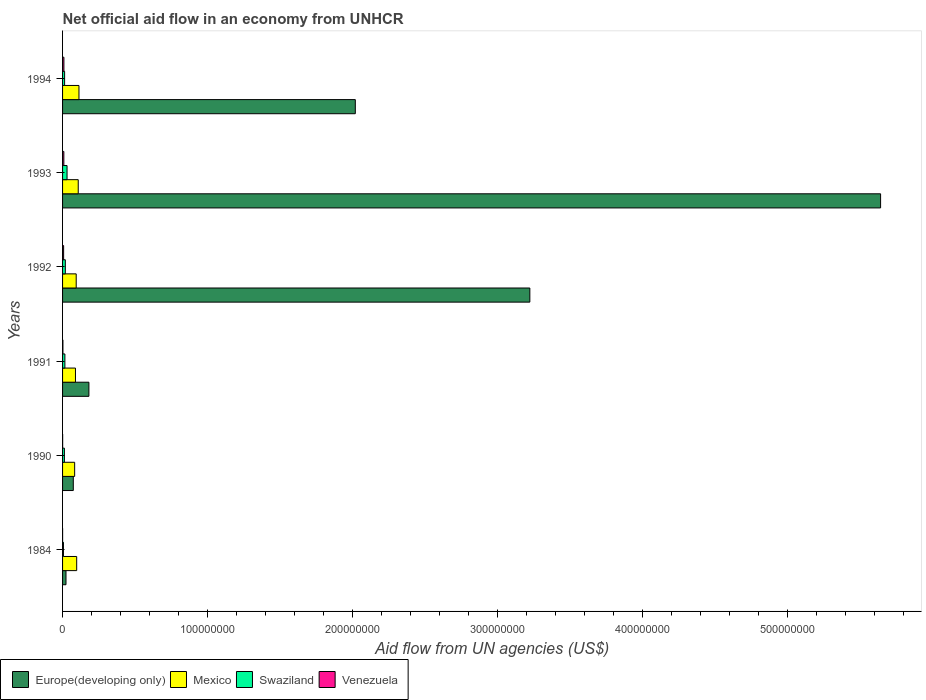Are the number of bars on each tick of the Y-axis equal?
Give a very brief answer. Yes. How many bars are there on the 2nd tick from the top?
Your answer should be compact. 4. What is the label of the 4th group of bars from the top?
Make the answer very short. 1991. In how many cases, is the number of bars for a given year not equal to the number of legend labels?
Give a very brief answer. 0. What is the net official aid flow in Venezuela in 1993?
Your answer should be compact. 8.80e+05. Across all years, what is the maximum net official aid flow in Europe(developing only)?
Keep it short and to the point. 5.64e+08. Across all years, what is the minimum net official aid flow in Venezuela?
Provide a short and direct response. 2.00e+04. What is the total net official aid flow in Europe(developing only) in the graph?
Keep it short and to the point. 1.12e+09. What is the difference between the net official aid flow in Europe(developing only) in 1984 and that in 1994?
Your answer should be very brief. -2.00e+08. What is the difference between the net official aid flow in Mexico in 1990 and the net official aid flow in Europe(developing only) in 1984?
Keep it short and to the point. 5.97e+06. What is the average net official aid flow in Mexico per year?
Give a very brief answer. 9.75e+06. In the year 1990, what is the difference between the net official aid flow in Mexico and net official aid flow in Venezuela?
Offer a very short reply. 8.29e+06. In how many years, is the net official aid flow in Swaziland greater than 200000000 US$?
Offer a terse response. 0. What is the ratio of the net official aid flow in Europe(developing only) in 1992 to that in 1994?
Keep it short and to the point. 1.6. Is the net official aid flow in Swaziland in 1990 less than that in 1993?
Ensure brevity in your answer.  Yes. What is the difference between the highest and the second highest net official aid flow in Venezuela?
Offer a terse response. 4.00e+04. What does the 2nd bar from the top in 1993 represents?
Provide a short and direct response. Swaziland. What does the 4th bar from the bottom in 1990 represents?
Keep it short and to the point. Venezuela. Is it the case that in every year, the sum of the net official aid flow in Mexico and net official aid flow in Venezuela is greater than the net official aid flow in Swaziland?
Your response must be concise. Yes. How many years are there in the graph?
Your response must be concise. 6. What is the difference between two consecutive major ticks on the X-axis?
Ensure brevity in your answer.  1.00e+08. Are the values on the major ticks of X-axis written in scientific E-notation?
Offer a terse response. No. Where does the legend appear in the graph?
Your answer should be very brief. Bottom left. How are the legend labels stacked?
Offer a very short reply. Horizontal. What is the title of the graph?
Make the answer very short. Net official aid flow in an economy from UNHCR. What is the label or title of the X-axis?
Provide a succinct answer. Aid flow from UN agencies (US$). What is the label or title of the Y-axis?
Provide a short and direct response. Years. What is the Aid flow from UN agencies (US$) of Europe(developing only) in 1984?
Provide a short and direct response. 2.37e+06. What is the Aid flow from UN agencies (US$) of Mexico in 1984?
Provide a succinct answer. 9.74e+06. What is the Aid flow from UN agencies (US$) of Europe(developing only) in 1990?
Provide a short and direct response. 7.40e+06. What is the Aid flow from UN agencies (US$) in Mexico in 1990?
Make the answer very short. 8.34e+06. What is the Aid flow from UN agencies (US$) in Swaziland in 1990?
Provide a short and direct response. 1.27e+06. What is the Aid flow from UN agencies (US$) in Europe(developing only) in 1991?
Ensure brevity in your answer.  1.82e+07. What is the Aid flow from UN agencies (US$) of Mexico in 1991?
Give a very brief answer. 8.90e+06. What is the Aid flow from UN agencies (US$) of Swaziland in 1991?
Offer a terse response. 1.60e+06. What is the Aid flow from UN agencies (US$) of Europe(developing only) in 1992?
Make the answer very short. 3.22e+08. What is the Aid flow from UN agencies (US$) of Mexico in 1992?
Your answer should be very brief. 9.40e+06. What is the Aid flow from UN agencies (US$) in Swaziland in 1992?
Offer a very short reply. 1.90e+06. What is the Aid flow from UN agencies (US$) of Venezuela in 1992?
Provide a short and direct response. 7.30e+05. What is the Aid flow from UN agencies (US$) of Europe(developing only) in 1993?
Provide a succinct answer. 5.64e+08. What is the Aid flow from UN agencies (US$) of Mexico in 1993?
Ensure brevity in your answer.  1.08e+07. What is the Aid flow from UN agencies (US$) in Swaziland in 1993?
Your answer should be compact. 3.09e+06. What is the Aid flow from UN agencies (US$) of Venezuela in 1993?
Offer a terse response. 8.80e+05. What is the Aid flow from UN agencies (US$) of Europe(developing only) in 1994?
Offer a terse response. 2.02e+08. What is the Aid flow from UN agencies (US$) in Mexico in 1994?
Your answer should be compact. 1.13e+07. What is the Aid flow from UN agencies (US$) in Swaziland in 1994?
Make the answer very short. 1.41e+06. What is the Aid flow from UN agencies (US$) of Venezuela in 1994?
Your answer should be compact. 9.20e+05. Across all years, what is the maximum Aid flow from UN agencies (US$) in Europe(developing only)?
Provide a succinct answer. 5.64e+08. Across all years, what is the maximum Aid flow from UN agencies (US$) of Mexico?
Your response must be concise. 1.13e+07. Across all years, what is the maximum Aid flow from UN agencies (US$) of Swaziland?
Your response must be concise. 3.09e+06. Across all years, what is the maximum Aid flow from UN agencies (US$) of Venezuela?
Your answer should be compact. 9.20e+05. Across all years, what is the minimum Aid flow from UN agencies (US$) in Europe(developing only)?
Your answer should be compact. 2.37e+06. Across all years, what is the minimum Aid flow from UN agencies (US$) of Mexico?
Your response must be concise. 8.34e+06. What is the total Aid flow from UN agencies (US$) of Europe(developing only) in the graph?
Your response must be concise. 1.12e+09. What is the total Aid flow from UN agencies (US$) in Mexico in the graph?
Provide a short and direct response. 5.85e+07. What is the total Aid flow from UN agencies (US$) in Swaziland in the graph?
Make the answer very short. 9.88e+06. What is the total Aid flow from UN agencies (US$) in Venezuela in the graph?
Your answer should be compact. 2.85e+06. What is the difference between the Aid flow from UN agencies (US$) in Europe(developing only) in 1984 and that in 1990?
Offer a terse response. -5.03e+06. What is the difference between the Aid flow from UN agencies (US$) of Mexico in 1984 and that in 1990?
Give a very brief answer. 1.40e+06. What is the difference between the Aid flow from UN agencies (US$) in Swaziland in 1984 and that in 1990?
Your answer should be compact. -6.60e+05. What is the difference between the Aid flow from UN agencies (US$) in Europe(developing only) in 1984 and that in 1991?
Keep it short and to the point. -1.58e+07. What is the difference between the Aid flow from UN agencies (US$) in Mexico in 1984 and that in 1991?
Offer a very short reply. 8.40e+05. What is the difference between the Aid flow from UN agencies (US$) in Swaziland in 1984 and that in 1991?
Offer a very short reply. -9.90e+05. What is the difference between the Aid flow from UN agencies (US$) of Europe(developing only) in 1984 and that in 1992?
Offer a terse response. -3.20e+08. What is the difference between the Aid flow from UN agencies (US$) in Swaziland in 1984 and that in 1992?
Ensure brevity in your answer.  -1.29e+06. What is the difference between the Aid flow from UN agencies (US$) of Venezuela in 1984 and that in 1992?
Offer a terse response. -7.10e+05. What is the difference between the Aid flow from UN agencies (US$) of Europe(developing only) in 1984 and that in 1993?
Ensure brevity in your answer.  -5.62e+08. What is the difference between the Aid flow from UN agencies (US$) in Mexico in 1984 and that in 1993?
Your answer should be compact. -1.07e+06. What is the difference between the Aid flow from UN agencies (US$) in Swaziland in 1984 and that in 1993?
Provide a succinct answer. -2.48e+06. What is the difference between the Aid flow from UN agencies (US$) of Venezuela in 1984 and that in 1993?
Your response must be concise. -8.60e+05. What is the difference between the Aid flow from UN agencies (US$) in Europe(developing only) in 1984 and that in 1994?
Offer a very short reply. -2.00e+08. What is the difference between the Aid flow from UN agencies (US$) in Mexico in 1984 and that in 1994?
Your answer should be very brief. -1.57e+06. What is the difference between the Aid flow from UN agencies (US$) in Swaziland in 1984 and that in 1994?
Keep it short and to the point. -8.00e+05. What is the difference between the Aid flow from UN agencies (US$) in Venezuela in 1984 and that in 1994?
Make the answer very short. -9.00e+05. What is the difference between the Aid flow from UN agencies (US$) of Europe(developing only) in 1990 and that in 1991?
Your response must be concise. -1.08e+07. What is the difference between the Aid flow from UN agencies (US$) of Mexico in 1990 and that in 1991?
Provide a succinct answer. -5.60e+05. What is the difference between the Aid flow from UN agencies (US$) of Swaziland in 1990 and that in 1991?
Your answer should be compact. -3.30e+05. What is the difference between the Aid flow from UN agencies (US$) in Venezuela in 1990 and that in 1991?
Your answer should be very brief. -2.00e+05. What is the difference between the Aid flow from UN agencies (US$) of Europe(developing only) in 1990 and that in 1992?
Your answer should be very brief. -3.15e+08. What is the difference between the Aid flow from UN agencies (US$) of Mexico in 1990 and that in 1992?
Provide a short and direct response. -1.06e+06. What is the difference between the Aid flow from UN agencies (US$) of Swaziland in 1990 and that in 1992?
Offer a very short reply. -6.30e+05. What is the difference between the Aid flow from UN agencies (US$) of Venezuela in 1990 and that in 1992?
Your answer should be compact. -6.80e+05. What is the difference between the Aid flow from UN agencies (US$) in Europe(developing only) in 1990 and that in 1993?
Ensure brevity in your answer.  -5.57e+08. What is the difference between the Aid flow from UN agencies (US$) of Mexico in 1990 and that in 1993?
Your response must be concise. -2.47e+06. What is the difference between the Aid flow from UN agencies (US$) of Swaziland in 1990 and that in 1993?
Your answer should be very brief. -1.82e+06. What is the difference between the Aid flow from UN agencies (US$) of Venezuela in 1990 and that in 1993?
Provide a short and direct response. -8.30e+05. What is the difference between the Aid flow from UN agencies (US$) in Europe(developing only) in 1990 and that in 1994?
Make the answer very short. -1.94e+08. What is the difference between the Aid flow from UN agencies (US$) of Mexico in 1990 and that in 1994?
Make the answer very short. -2.97e+06. What is the difference between the Aid flow from UN agencies (US$) of Swaziland in 1990 and that in 1994?
Provide a short and direct response. -1.40e+05. What is the difference between the Aid flow from UN agencies (US$) in Venezuela in 1990 and that in 1994?
Keep it short and to the point. -8.70e+05. What is the difference between the Aid flow from UN agencies (US$) of Europe(developing only) in 1991 and that in 1992?
Offer a very short reply. -3.04e+08. What is the difference between the Aid flow from UN agencies (US$) of Mexico in 1991 and that in 1992?
Offer a very short reply. -5.00e+05. What is the difference between the Aid flow from UN agencies (US$) in Venezuela in 1991 and that in 1992?
Provide a short and direct response. -4.80e+05. What is the difference between the Aid flow from UN agencies (US$) in Europe(developing only) in 1991 and that in 1993?
Your answer should be compact. -5.46e+08. What is the difference between the Aid flow from UN agencies (US$) in Mexico in 1991 and that in 1993?
Your answer should be very brief. -1.91e+06. What is the difference between the Aid flow from UN agencies (US$) of Swaziland in 1991 and that in 1993?
Your response must be concise. -1.49e+06. What is the difference between the Aid flow from UN agencies (US$) in Venezuela in 1991 and that in 1993?
Ensure brevity in your answer.  -6.30e+05. What is the difference between the Aid flow from UN agencies (US$) in Europe(developing only) in 1991 and that in 1994?
Your answer should be very brief. -1.84e+08. What is the difference between the Aid flow from UN agencies (US$) of Mexico in 1991 and that in 1994?
Your answer should be compact. -2.41e+06. What is the difference between the Aid flow from UN agencies (US$) in Swaziland in 1991 and that in 1994?
Your answer should be compact. 1.90e+05. What is the difference between the Aid flow from UN agencies (US$) of Venezuela in 1991 and that in 1994?
Provide a short and direct response. -6.70e+05. What is the difference between the Aid flow from UN agencies (US$) in Europe(developing only) in 1992 and that in 1993?
Keep it short and to the point. -2.42e+08. What is the difference between the Aid flow from UN agencies (US$) of Mexico in 1992 and that in 1993?
Offer a very short reply. -1.41e+06. What is the difference between the Aid flow from UN agencies (US$) in Swaziland in 1992 and that in 1993?
Your answer should be compact. -1.19e+06. What is the difference between the Aid flow from UN agencies (US$) in Venezuela in 1992 and that in 1993?
Provide a short and direct response. -1.50e+05. What is the difference between the Aid flow from UN agencies (US$) in Europe(developing only) in 1992 and that in 1994?
Your answer should be very brief. 1.20e+08. What is the difference between the Aid flow from UN agencies (US$) of Mexico in 1992 and that in 1994?
Your answer should be very brief. -1.91e+06. What is the difference between the Aid flow from UN agencies (US$) of Venezuela in 1992 and that in 1994?
Keep it short and to the point. -1.90e+05. What is the difference between the Aid flow from UN agencies (US$) in Europe(developing only) in 1993 and that in 1994?
Provide a short and direct response. 3.62e+08. What is the difference between the Aid flow from UN agencies (US$) in Mexico in 1993 and that in 1994?
Provide a short and direct response. -5.00e+05. What is the difference between the Aid flow from UN agencies (US$) in Swaziland in 1993 and that in 1994?
Ensure brevity in your answer.  1.68e+06. What is the difference between the Aid flow from UN agencies (US$) in Europe(developing only) in 1984 and the Aid flow from UN agencies (US$) in Mexico in 1990?
Your response must be concise. -5.97e+06. What is the difference between the Aid flow from UN agencies (US$) in Europe(developing only) in 1984 and the Aid flow from UN agencies (US$) in Swaziland in 1990?
Your answer should be compact. 1.10e+06. What is the difference between the Aid flow from UN agencies (US$) of Europe(developing only) in 1984 and the Aid flow from UN agencies (US$) of Venezuela in 1990?
Your answer should be very brief. 2.32e+06. What is the difference between the Aid flow from UN agencies (US$) in Mexico in 1984 and the Aid flow from UN agencies (US$) in Swaziland in 1990?
Offer a terse response. 8.47e+06. What is the difference between the Aid flow from UN agencies (US$) in Mexico in 1984 and the Aid flow from UN agencies (US$) in Venezuela in 1990?
Your answer should be very brief. 9.69e+06. What is the difference between the Aid flow from UN agencies (US$) of Swaziland in 1984 and the Aid flow from UN agencies (US$) of Venezuela in 1990?
Provide a short and direct response. 5.60e+05. What is the difference between the Aid flow from UN agencies (US$) in Europe(developing only) in 1984 and the Aid flow from UN agencies (US$) in Mexico in 1991?
Your answer should be very brief. -6.53e+06. What is the difference between the Aid flow from UN agencies (US$) in Europe(developing only) in 1984 and the Aid flow from UN agencies (US$) in Swaziland in 1991?
Keep it short and to the point. 7.70e+05. What is the difference between the Aid flow from UN agencies (US$) in Europe(developing only) in 1984 and the Aid flow from UN agencies (US$) in Venezuela in 1991?
Your answer should be compact. 2.12e+06. What is the difference between the Aid flow from UN agencies (US$) in Mexico in 1984 and the Aid flow from UN agencies (US$) in Swaziland in 1991?
Your response must be concise. 8.14e+06. What is the difference between the Aid flow from UN agencies (US$) of Mexico in 1984 and the Aid flow from UN agencies (US$) of Venezuela in 1991?
Your answer should be very brief. 9.49e+06. What is the difference between the Aid flow from UN agencies (US$) of Swaziland in 1984 and the Aid flow from UN agencies (US$) of Venezuela in 1991?
Your response must be concise. 3.60e+05. What is the difference between the Aid flow from UN agencies (US$) in Europe(developing only) in 1984 and the Aid flow from UN agencies (US$) in Mexico in 1992?
Provide a succinct answer. -7.03e+06. What is the difference between the Aid flow from UN agencies (US$) of Europe(developing only) in 1984 and the Aid flow from UN agencies (US$) of Venezuela in 1992?
Keep it short and to the point. 1.64e+06. What is the difference between the Aid flow from UN agencies (US$) in Mexico in 1984 and the Aid flow from UN agencies (US$) in Swaziland in 1992?
Keep it short and to the point. 7.84e+06. What is the difference between the Aid flow from UN agencies (US$) in Mexico in 1984 and the Aid flow from UN agencies (US$) in Venezuela in 1992?
Your answer should be very brief. 9.01e+06. What is the difference between the Aid flow from UN agencies (US$) in Swaziland in 1984 and the Aid flow from UN agencies (US$) in Venezuela in 1992?
Provide a succinct answer. -1.20e+05. What is the difference between the Aid flow from UN agencies (US$) in Europe(developing only) in 1984 and the Aid flow from UN agencies (US$) in Mexico in 1993?
Make the answer very short. -8.44e+06. What is the difference between the Aid flow from UN agencies (US$) in Europe(developing only) in 1984 and the Aid flow from UN agencies (US$) in Swaziland in 1993?
Your answer should be very brief. -7.20e+05. What is the difference between the Aid flow from UN agencies (US$) in Europe(developing only) in 1984 and the Aid flow from UN agencies (US$) in Venezuela in 1993?
Provide a short and direct response. 1.49e+06. What is the difference between the Aid flow from UN agencies (US$) in Mexico in 1984 and the Aid flow from UN agencies (US$) in Swaziland in 1993?
Make the answer very short. 6.65e+06. What is the difference between the Aid flow from UN agencies (US$) of Mexico in 1984 and the Aid flow from UN agencies (US$) of Venezuela in 1993?
Ensure brevity in your answer.  8.86e+06. What is the difference between the Aid flow from UN agencies (US$) of Swaziland in 1984 and the Aid flow from UN agencies (US$) of Venezuela in 1993?
Offer a terse response. -2.70e+05. What is the difference between the Aid flow from UN agencies (US$) in Europe(developing only) in 1984 and the Aid flow from UN agencies (US$) in Mexico in 1994?
Give a very brief answer. -8.94e+06. What is the difference between the Aid flow from UN agencies (US$) in Europe(developing only) in 1984 and the Aid flow from UN agencies (US$) in Swaziland in 1994?
Your answer should be very brief. 9.60e+05. What is the difference between the Aid flow from UN agencies (US$) in Europe(developing only) in 1984 and the Aid flow from UN agencies (US$) in Venezuela in 1994?
Ensure brevity in your answer.  1.45e+06. What is the difference between the Aid flow from UN agencies (US$) in Mexico in 1984 and the Aid flow from UN agencies (US$) in Swaziland in 1994?
Keep it short and to the point. 8.33e+06. What is the difference between the Aid flow from UN agencies (US$) of Mexico in 1984 and the Aid flow from UN agencies (US$) of Venezuela in 1994?
Your response must be concise. 8.82e+06. What is the difference between the Aid flow from UN agencies (US$) in Swaziland in 1984 and the Aid flow from UN agencies (US$) in Venezuela in 1994?
Give a very brief answer. -3.10e+05. What is the difference between the Aid flow from UN agencies (US$) of Europe(developing only) in 1990 and the Aid flow from UN agencies (US$) of Mexico in 1991?
Offer a very short reply. -1.50e+06. What is the difference between the Aid flow from UN agencies (US$) in Europe(developing only) in 1990 and the Aid flow from UN agencies (US$) in Swaziland in 1991?
Provide a short and direct response. 5.80e+06. What is the difference between the Aid flow from UN agencies (US$) in Europe(developing only) in 1990 and the Aid flow from UN agencies (US$) in Venezuela in 1991?
Provide a succinct answer. 7.15e+06. What is the difference between the Aid flow from UN agencies (US$) in Mexico in 1990 and the Aid flow from UN agencies (US$) in Swaziland in 1991?
Your answer should be compact. 6.74e+06. What is the difference between the Aid flow from UN agencies (US$) in Mexico in 1990 and the Aid flow from UN agencies (US$) in Venezuela in 1991?
Ensure brevity in your answer.  8.09e+06. What is the difference between the Aid flow from UN agencies (US$) of Swaziland in 1990 and the Aid flow from UN agencies (US$) of Venezuela in 1991?
Provide a short and direct response. 1.02e+06. What is the difference between the Aid flow from UN agencies (US$) of Europe(developing only) in 1990 and the Aid flow from UN agencies (US$) of Mexico in 1992?
Provide a succinct answer. -2.00e+06. What is the difference between the Aid flow from UN agencies (US$) in Europe(developing only) in 1990 and the Aid flow from UN agencies (US$) in Swaziland in 1992?
Your answer should be compact. 5.50e+06. What is the difference between the Aid flow from UN agencies (US$) of Europe(developing only) in 1990 and the Aid flow from UN agencies (US$) of Venezuela in 1992?
Keep it short and to the point. 6.67e+06. What is the difference between the Aid flow from UN agencies (US$) of Mexico in 1990 and the Aid flow from UN agencies (US$) of Swaziland in 1992?
Your response must be concise. 6.44e+06. What is the difference between the Aid flow from UN agencies (US$) of Mexico in 1990 and the Aid flow from UN agencies (US$) of Venezuela in 1992?
Offer a terse response. 7.61e+06. What is the difference between the Aid flow from UN agencies (US$) in Swaziland in 1990 and the Aid flow from UN agencies (US$) in Venezuela in 1992?
Keep it short and to the point. 5.40e+05. What is the difference between the Aid flow from UN agencies (US$) in Europe(developing only) in 1990 and the Aid flow from UN agencies (US$) in Mexico in 1993?
Keep it short and to the point. -3.41e+06. What is the difference between the Aid flow from UN agencies (US$) of Europe(developing only) in 1990 and the Aid flow from UN agencies (US$) of Swaziland in 1993?
Ensure brevity in your answer.  4.31e+06. What is the difference between the Aid flow from UN agencies (US$) of Europe(developing only) in 1990 and the Aid flow from UN agencies (US$) of Venezuela in 1993?
Provide a short and direct response. 6.52e+06. What is the difference between the Aid flow from UN agencies (US$) in Mexico in 1990 and the Aid flow from UN agencies (US$) in Swaziland in 1993?
Your response must be concise. 5.25e+06. What is the difference between the Aid flow from UN agencies (US$) in Mexico in 1990 and the Aid flow from UN agencies (US$) in Venezuela in 1993?
Offer a very short reply. 7.46e+06. What is the difference between the Aid flow from UN agencies (US$) in Swaziland in 1990 and the Aid flow from UN agencies (US$) in Venezuela in 1993?
Keep it short and to the point. 3.90e+05. What is the difference between the Aid flow from UN agencies (US$) of Europe(developing only) in 1990 and the Aid flow from UN agencies (US$) of Mexico in 1994?
Offer a terse response. -3.91e+06. What is the difference between the Aid flow from UN agencies (US$) in Europe(developing only) in 1990 and the Aid flow from UN agencies (US$) in Swaziland in 1994?
Provide a short and direct response. 5.99e+06. What is the difference between the Aid flow from UN agencies (US$) in Europe(developing only) in 1990 and the Aid flow from UN agencies (US$) in Venezuela in 1994?
Offer a very short reply. 6.48e+06. What is the difference between the Aid flow from UN agencies (US$) of Mexico in 1990 and the Aid flow from UN agencies (US$) of Swaziland in 1994?
Provide a short and direct response. 6.93e+06. What is the difference between the Aid flow from UN agencies (US$) in Mexico in 1990 and the Aid flow from UN agencies (US$) in Venezuela in 1994?
Make the answer very short. 7.42e+06. What is the difference between the Aid flow from UN agencies (US$) of Swaziland in 1990 and the Aid flow from UN agencies (US$) of Venezuela in 1994?
Offer a terse response. 3.50e+05. What is the difference between the Aid flow from UN agencies (US$) in Europe(developing only) in 1991 and the Aid flow from UN agencies (US$) in Mexico in 1992?
Ensure brevity in your answer.  8.76e+06. What is the difference between the Aid flow from UN agencies (US$) in Europe(developing only) in 1991 and the Aid flow from UN agencies (US$) in Swaziland in 1992?
Keep it short and to the point. 1.63e+07. What is the difference between the Aid flow from UN agencies (US$) of Europe(developing only) in 1991 and the Aid flow from UN agencies (US$) of Venezuela in 1992?
Make the answer very short. 1.74e+07. What is the difference between the Aid flow from UN agencies (US$) in Mexico in 1991 and the Aid flow from UN agencies (US$) in Swaziland in 1992?
Your response must be concise. 7.00e+06. What is the difference between the Aid flow from UN agencies (US$) of Mexico in 1991 and the Aid flow from UN agencies (US$) of Venezuela in 1992?
Ensure brevity in your answer.  8.17e+06. What is the difference between the Aid flow from UN agencies (US$) in Swaziland in 1991 and the Aid flow from UN agencies (US$) in Venezuela in 1992?
Make the answer very short. 8.70e+05. What is the difference between the Aid flow from UN agencies (US$) in Europe(developing only) in 1991 and the Aid flow from UN agencies (US$) in Mexico in 1993?
Your response must be concise. 7.35e+06. What is the difference between the Aid flow from UN agencies (US$) in Europe(developing only) in 1991 and the Aid flow from UN agencies (US$) in Swaziland in 1993?
Make the answer very short. 1.51e+07. What is the difference between the Aid flow from UN agencies (US$) in Europe(developing only) in 1991 and the Aid flow from UN agencies (US$) in Venezuela in 1993?
Provide a short and direct response. 1.73e+07. What is the difference between the Aid flow from UN agencies (US$) of Mexico in 1991 and the Aid flow from UN agencies (US$) of Swaziland in 1993?
Your response must be concise. 5.81e+06. What is the difference between the Aid flow from UN agencies (US$) in Mexico in 1991 and the Aid flow from UN agencies (US$) in Venezuela in 1993?
Your answer should be very brief. 8.02e+06. What is the difference between the Aid flow from UN agencies (US$) of Swaziland in 1991 and the Aid flow from UN agencies (US$) of Venezuela in 1993?
Keep it short and to the point. 7.20e+05. What is the difference between the Aid flow from UN agencies (US$) of Europe(developing only) in 1991 and the Aid flow from UN agencies (US$) of Mexico in 1994?
Make the answer very short. 6.85e+06. What is the difference between the Aid flow from UN agencies (US$) in Europe(developing only) in 1991 and the Aid flow from UN agencies (US$) in Swaziland in 1994?
Your answer should be compact. 1.68e+07. What is the difference between the Aid flow from UN agencies (US$) in Europe(developing only) in 1991 and the Aid flow from UN agencies (US$) in Venezuela in 1994?
Your answer should be compact. 1.72e+07. What is the difference between the Aid flow from UN agencies (US$) in Mexico in 1991 and the Aid flow from UN agencies (US$) in Swaziland in 1994?
Provide a succinct answer. 7.49e+06. What is the difference between the Aid flow from UN agencies (US$) of Mexico in 1991 and the Aid flow from UN agencies (US$) of Venezuela in 1994?
Ensure brevity in your answer.  7.98e+06. What is the difference between the Aid flow from UN agencies (US$) in Swaziland in 1991 and the Aid flow from UN agencies (US$) in Venezuela in 1994?
Ensure brevity in your answer.  6.80e+05. What is the difference between the Aid flow from UN agencies (US$) in Europe(developing only) in 1992 and the Aid flow from UN agencies (US$) in Mexico in 1993?
Give a very brief answer. 3.11e+08. What is the difference between the Aid flow from UN agencies (US$) in Europe(developing only) in 1992 and the Aid flow from UN agencies (US$) in Swaziland in 1993?
Your response must be concise. 3.19e+08. What is the difference between the Aid flow from UN agencies (US$) of Europe(developing only) in 1992 and the Aid flow from UN agencies (US$) of Venezuela in 1993?
Your answer should be compact. 3.21e+08. What is the difference between the Aid flow from UN agencies (US$) in Mexico in 1992 and the Aid flow from UN agencies (US$) in Swaziland in 1993?
Your answer should be very brief. 6.31e+06. What is the difference between the Aid flow from UN agencies (US$) of Mexico in 1992 and the Aid flow from UN agencies (US$) of Venezuela in 1993?
Ensure brevity in your answer.  8.52e+06. What is the difference between the Aid flow from UN agencies (US$) of Swaziland in 1992 and the Aid flow from UN agencies (US$) of Venezuela in 1993?
Provide a succinct answer. 1.02e+06. What is the difference between the Aid flow from UN agencies (US$) of Europe(developing only) in 1992 and the Aid flow from UN agencies (US$) of Mexico in 1994?
Offer a terse response. 3.11e+08. What is the difference between the Aid flow from UN agencies (US$) in Europe(developing only) in 1992 and the Aid flow from UN agencies (US$) in Swaziland in 1994?
Make the answer very short. 3.21e+08. What is the difference between the Aid flow from UN agencies (US$) of Europe(developing only) in 1992 and the Aid flow from UN agencies (US$) of Venezuela in 1994?
Your answer should be compact. 3.21e+08. What is the difference between the Aid flow from UN agencies (US$) in Mexico in 1992 and the Aid flow from UN agencies (US$) in Swaziland in 1994?
Provide a succinct answer. 7.99e+06. What is the difference between the Aid flow from UN agencies (US$) of Mexico in 1992 and the Aid flow from UN agencies (US$) of Venezuela in 1994?
Provide a short and direct response. 8.48e+06. What is the difference between the Aid flow from UN agencies (US$) of Swaziland in 1992 and the Aid flow from UN agencies (US$) of Venezuela in 1994?
Provide a short and direct response. 9.80e+05. What is the difference between the Aid flow from UN agencies (US$) of Europe(developing only) in 1993 and the Aid flow from UN agencies (US$) of Mexico in 1994?
Keep it short and to the point. 5.53e+08. What is the difference between the Aid flow from UN agencies (US$) of Europe(developing only) in 1993 and the Aid flow from UN agencies (US$) of Swaziland in 1994?
Offer a very short reply. 5.63e+08. What is the difference between the Aid flow from UN agencies (US$) in Europe(developing only) in 1993 and the Aid flow from UN agencies (US$) in Venezuela in 1994?
Keep it short and to the point. 5.63e+08. What is the difference between the Aid flow from UN agencies (US$) in Mexico in 1993 and the Aid flow from UN agencies (US$) in Swaziland in 1994?
Make the answer very short. 9.40e+06. What is the difference between the Aid flow from UN agencies (US$) of Mexico in 1993 and the Aid flow from UN agencies (US$) of Venezuela in 1994?
Give a very brief answer. 9.89e+06. What is the difference between the Aid flow from UN agencies (US$) of Swaziland in 1993 and the Aid flow from UN agencies (US$) of Venezuela in 1994?
Give a very brief answer. 2.17e+06. What is the average Aid flow from UN agencies (US$) of Europe(developing only) per year?
Give a very brief answer. 1.86e+08. What is the average Aid flow from UN agencies (US$) in Mexico per year?
Offer a very short reply. 9.75e+06. What is the average Aid flow from UN agencies (US$) in Swaziland per year?
Give a very brief answer. 1.65e+06. What is the average Aid flow from UN agencies (US$) in Venezuela per year?
Offer a terse response. 4.75e+05. In the year 1984, what is the difference between the Aid flow from UN agencies (US$) of Europe(developing only) and Aid flow from UN agencies (US$) of Mexico?
Provide a succinct answer. -7.37e+06. In the year 1984, what is the difference between the Aid flow from UN agencies (US$) in Europe(developing only) and Aid flow from UN agencies (US$) in Swaziland?
Your answer should be very brief. 1.76e+06. In the year 1984, what is the difference between the Aid flow from UN agencies (US$) of Europe(developing only) and Aid flow from UN agencies (US$) of Venezuela?
Offer a very short reply. 2.35e+06. In the year 1984, what is the difference between the Aid flow from UN agencies (US$) in Mexico and Aid flow from UN agencies (US$) in Swaziland?
Ensure brevity in your answer.  9.13e+06. In the year 1984, what is the difference between the Aid flow from UN agencies (US$) of Mexico and Aid flow from UN agencies (US$) of Venezuela?
Offer a very short reply. 9.72e+06. In the year 1984, what is the difference between the Aid flow from UN agencies (US$) of Swaziland and Aid flow from UN agencies (US$) of Venezuela?
Ensure brevity in your answer.  5.90e+05. In the year 1990, what is the difference between the Aid flow from UN agencies (US$) of Europe(developing only) and Aid flow from UN agencies (US$) of Mexico?
Keep it short and to the point. -9.40e+05. In the year 1990, what is the difference between the Aid flow from UN agencies (US$) in Europe(developing only) and Aid flow from UN agencies (US$) in Swaziland?
Provide a succinct answer. 6.13e+06. In the year 1990, what is the difference between the Aid flow from UN agencies (US$) in Europe(developing only) and Aid flow from UN agencies (US$) in Venezuela?
Offer a very short reply. 7.35e+06. In the year 1990, what is the difference between the Aid flow from UN agencies (US$) in Mexico and Aid flow from UN agencies (US$) in Swaziland?
Your response must be concise. 7.07e+06. In the year 1990, what is the difference between the Aid flow from UN agencies (US$) of Mexico and Aid flow from UN agencies (US$) of Venezuela?
Make the answer very short. 8.29e+06. In the year 1990, what is the difference between the Aid flow from UN agencies (US$) of Swaziland and Aid flow from UN agencies (US$) of Venezuela?
Provide a succinct answer. 1.22e+06. In the year 1991, what is the difference between the Aid flow from UN agencies (US$) in Europe(developing only) and Aid flow from UN agencies (US$) in Mexico?
Offer a very short reply. 9.26e+06. In the year 1991, what is the difference between the Aid flow from UN agencies (US$) in Europe(developing only) and Aid flow from UN agencies (US$) in Swaziland?
Provide a short and direct response. 1.66e+07. In the year 1991, what is the difference between the Aid flow from UN agencies (US$) of Europe(developing only) and Aid flow from UN agencies (US$) of Venezuela?
Your answer should be compact. 1.79e+07. In the year 1991, what is the difference between the Aid flow from UN agencies (US$) of Mexico and Aid flow from UN agencies (US$) of Swaziland?
Provide a short and direct response. 7.30e+06. In the year 1991, what is the difference between the Aid flow from UN agencies (US$) of Mexico and Aid flow from UN agencies (US$) of Venezuela?
Provide a short and direct response. 8.65e+06. In the year 1991, what is the difference between the Aid flow from UN agencies (US$) of Swaziland and Aid flow from UN agencies (US$) of Venezuela?
Offer a terse response. 1.35e+06. In the year 1992, what is the difference between the Aid flow from UN agencies (US$) of Europe(developing only) and Aid flow from UN agencies (US$) of Mexico?
Make the answer very short. 3.13e+08. In the year 1992, what is the difference between the Aid flow from UN agencies (US$) of Europe(developing only) and Aid flow from UN agencies (US$) of Swaziland?
Offer a terse response. 3.20e+08. In the year 1992, what is the difference between the Aid flow from UN agencies (US$) of Europe(developing only) and Aid flow from UN agencies (US$) of Venezuela?
Make the answer very short. 3.22e+08. In the year 1992, what is the difference between the Aid flow from UN agencies (US$) of Mexico and Aid flow from UN agencies (US$) of Swaziland?
Keep it short and to the point. 7.50e+06. In the year 1992, what is the difference between the Aid flow from UN agencies (US$) in Mexico and Aid flow from UN agencies (US$) in Venezuela?
Keep it short and to the point. 8.67e+06. In the year 1992, what is the difference between the Aid flow from UN agencies (US$) of Swaziland and Aid flow from UN agencies (US$) of Venezuela?
Offer a very short reply. 1.17e+06. In the year 1993, what is the difference between the Aid flow from UN agencies (US$) in Europe(developing only) and Aid flow from UN agencies (US$) in Mexico?
Offer a very short reply. 5.53e+08. In the year 1993, what is the difference between the Aid flow from UN agencies (US$) in Europe(developing only) and Aid flow from UN agencies (US$) in Swaziland?
Give a very brief answer. 5.61e+08. In the year 1993, what is the difference between the Aid flow from UN agencies (US$) of Europe(developing only) and Aid flow from UN agencies (US$) of Venezuela?
Keep it short and to the point. 5.63e+08. In the year 1993, what is the difference between the Aid flow from UN agencies (US$) of Mexico and Aid flow from UN agencies (US$) of Swaziland?
Provide a short and direct response. 7.72e+06. In the year 1993, what is the difference between the Aid flow from UN agencies (US$) of Mexico and Aid flow from UN agencies (US$) of Venezuela?
Offer a terse response. 9.93e+06. In the year 1993, what is the difference between the Aid flow from UN agencies (US$) of Swaziland and Aid flow from UN agencies (US$) of Venezuela?
Your answer should be very brief. 2.21e+06. In the year 1994, what is the difference between the Aid flow from UN agencies (US$) in Europe(developing only) and Aid flow from UN agencies (US$) in Mexico?
Ensure brevity in your answer.  1.91e+08. In the year 1994, what is the difference between the Aid flow from UN agencies (US$) in Europe(developing only) and Aid flow from UN agencies (US$) in Swaziland?
Your answer should be compact. 2.00e+08. In the year 1994, what is the difference between the Aid flow from UN agencies (US$) in Europe(developing only) and Aid flow from UN agencies (US$) in Venezuela?
Offer a very short reply. 2.01e+08. In the year 1994, what is the difference between the Aid flow from UN agencies (US$) of Mexico and Aid flow from UN agencies (US$) of Swaziland?
Give a very brief answer. 9.90e+06. In the year 1994, what is the difference between the Aid flow from UN agencies (US$) of Mexico and Aid flow from UN agencies (US$) of Venezuela?
Provide a short and direct response. 1.04e+07. What is the ratio of the Aid flow from UN agencies (US$) in Europe(developing only) in 1984 to that in 1990?
Keep it short and to the point. 0.32. What is the ratio of the Aid flow from UN agencies (US$) in Mexico in 1984 to that in 1990?
Offer a very short reply. 1.17. What is the ratio of the Aid flow from UN agencies (US$) in Swaziland in 1984 to that in 1990?
Offer a very short reply. 0.48. What is the ratio of the Aid flow from UN agencies (US$) in Venezuela in 1984 to that in 1990?
Provide a short and direct response. 0.4. What is the ratio of the Aid flow from UN agencies (US$) of Europe(developing only) in 1984 to that in 1991?
Your response must be concise. 0.13. What is the ratio of the Aid flow from UN agencies (US$) in Mexico in 1984 to that in 1991?
Offer a very short reply. 1.09. What is the ratio of the Aid flow from UN agencies (US$) in Swaziland in 1984 to that in 1991?
Provide a succinct answer. 0.38. What is the ratio of the Aid flow from UN agencies (US$) of Venezuela in 1984 to that in 1991?
Make the answer very short. 0.08. What is the ratio of the Aid flow from UN agencies (US$) of Europe(developing only) in 1984 to that in 1992?
Your answer should be compact. 0.01. What is the ratio of the Aid flow from UN agencies (US$) in Mexico in 1984 to that in 1992?
Provide a succinct answer. 1.04. What is the ratio of the Aid flow from UN agencies (US$) in Swaziland in 1984 to that in 1992?
Give a very brief answer. 0.32. What is the ratio of the Aid flow from UN agencies (US$) of Venezuela in 1984 to that in 1992?
Ensure brevity in your answer.  0.03. What is the ratio of the Aid flow from UN agencies (US$) of Europe(developing only) in 1984 to that in 1993?
Your response must be concise. 0. What is the ratio of the Aid flow from UN agencies (US$) of Mexico in 1984 to that in 1993?
Provide a short and direct response. 0.9. What is the ratio of the Aid flow from UN agencies (US$) in Swaziland in 1984 to that in 1993?
Provide a succinct answer. 0.2. What is the ratio of the Aid flow from UN agencies (US$) in Venezuela in 1984 to that in 1993?
Your answer should be compact. 0.02. What is the ratio of the Aid flow from UN agencies (US$) in Europe(developing only) in 1984 to that in 1994?
Ensure brevity in your answer.  0.01. What is the ratio of the Aid flow from UN agencies (US$) of Mexico in 1984 to that in 1994?
Keep it short and to the point. 0.86. What is the ratio of the Aid flow from UN agencies (US$) in Swaziland in 1984 to that in 1994?
Your answer should be compact. 0.43. What is the ratio of the Aid flow from UN agencies (US$) in Venezuela in 1984 to that in 1994?
Ensure brevity in your answer.  0.02. What is the ratio of the Aid flow from UN agencies (US$) of Europe(developing only) in 1990 to that in 1991?
Keep it short and to the point. 0.41. What is the ratio of the Aid flow from UN agencies (US$) in Mexico in 1990 to that in 1991?
Your response must be concise. 0.94. What is the ratio of the Aid flow from UN agencies (US$) of Swaziland in 1990 to that in 1991?
Provide a short and direct response. 0.79. What is the ratio of the Aid flow from UN agencies (US$) of Venezuela in 1990 to that in 1991?
Make the answer very short. 0.2. What is the ratio of the Aid flow from UN agencies (US$) of Europe(developing only) in 1990 to that in 1992?
Offer a terse response. 0.02. What is the ratio of the Aid flow from UN agencies (US$) in Mexico in 1990 to that in 1992?
Offer a very short reply. 0.89. What is the ratio of the Aid flow from UN agencies (US$) of Swaziland in 1990 to that in 1992?
Offer a terse response. 0.67. What is the ratio of the Aid flow from UN agencies (US$) in Venezuela in 1990 to that in 1992?
Make the answer very short. 0.07. What is the ratio of the Aid flow from UN agencies (US$) of Europe(developing only) in 1990 to that in 1993?
Offer a very short reply. 0.01. What is the ratio of the Aid flow from UN agencies (US$) in Mexico in 1990 to that in 1993?
Your answer should be very brief. 0.77. What is the ratio of the Aid flow from UN agencies (US$) of Swaziland in 1990 to that in 1993?
Ensure brevity in your answer.  0.41. What is the ratio of the Aid flow from UN agencies (US$) of Venezuela in 1990 to that in 1993?
Offer a terse response. 0.06. What is the ratio of the Aid flow from UN agencies (US$) of Europe(developing only) in 1990 to that in 1994?
Make the answer very short. 0.04. What is the ratio of the Aid flow from UN agencies (US$) in Mexico in 1990 to that in 1994?
Provide a succinct answer. 0.74. What is the ratio of the Aid flow from UN agencies (US$) in Swaziland in 1990 to that in 1994?
Keep it short and to the point. 0.9. What is the ratio of the Aid flow from UN agencies (US$) in Venezuela in 1990 to that in 1994?
Your response must be concise. 0.05. What is the ratio of the Aid flow from UN agencies (US$) of Europe(developing only) in 1991 to that in 1992?
Your answer should be compact. 0.06. What is the ratio of the Aid flow from UN agencies (US$) in Mexico in 1991 to that in 1992?
Make the answer very short. 0.95. What is the ratio of the Aid flow from UN agencies (US$) of Swaziland in 1991 to that in 1992?
Keep it short and to the point. 0.84. What is the ratio of the Aid flow from UN agencies (US$) in Venezuela in 1991 to that in 1992?
Ensure brevity in your answer.  0.34. What is the ratio of the Aid flow from UN agencies (US$) in Europe(developing only) in 1991 to that in 1993?
Provide a short and direct response. 0.03. What is the ratio of the Aid flow from UN agencies (US$) of Mexico in 1991 to that in 1993?
Offer a very short reply. 0.82. What is the ratio of the Aid flow from UN agencies (US$) of Swaziland in 1991 to that in 1993?
Keep it short and to the point. 0.52. What is the ratio of the Aid flow from UN agencies (US$) in Venezuela in 1991 to that in 1993?
Your answer should be compact. 0.28. What is the ratio of the Aid flow from UN agencies (US$) of Europe(developing only) in 1991 to that in 1994?
Your answer should be very brief. 0.09. What is the ratio of the Aid flow from UN agencies (US$) in Mexico in 1991 to that in 1994?
Keep it short and to the point. 0.79. What is the ratio of the Aid flow from UN agencies (US$) of Swaziland in 1991 to that in 1994?
Give a very brief answer. 1.13. What is the ratio of the Aid flow from UN agencies (US$) in Venezuela in 1991 to that in 1994?
Ensure brevity in your answer.  0.27. What is the ratio of the Aid flow from UN agencies (US$) in Europe(developing only) in 1992 to that in 1993?
Ensure brevity in your answer.  0.57. What is the ratio of the Aid flow from UN agencies (US$) in Mexico in 1992 to that in 1993?
Your response must be concise. 0.87. What is the ratio of the Aid flow from UN agencies (US$) of Swaziland in 1992 to that in 1993?
Keep it short and to the point. 0.61. What is the ratio of the Aid flow from UN agencies (US$) in Venezuela in 1992 to that in 1993?
Your response must be concise. 0.83. What is the ratio of the Aid flow from UN agencies (US$) of Europe(developing only) in 1992 to that in 1994?
Your answer should be compact. 1.6. What is the ratio of the Aid flow from UN agencies (US$) of Mexico in 1992 to that in 1994?
Provide a succinct answer. 0.83. What is the ratio of the Aid flow from UN agencies (US$) of Swaziland in 1992 to that in 1994?
Offer a terse response. 1.35. What is the ratio of the Aid flow from UN agencies (US$) in Venezuela in 1992 to that in 1994?
Offer a terse response. 0.79. What is the ratio of the Aid flow from UN agencies (US$) of Europe(developing only) in 1993 to that in 1994?
Keep it short and to the point. 2.79. What is the ratio of the Aid flow from UN agencies (US$) of Mexico in 1993 to that in 1994?
Your response must be concise. 0.96. What is the ratio of the Aid flow from UN agencies (US$) of Swaziland in 1993 to that in 1994?
Ensure brevity in your answer.  2.19. What is the ratio of the Aid flow from UN agencies (US$) in Venezuela in 1993 to that in 1994?
Keep it short and to the point. 0.96. What is the difference between the highest and the second highest Aid flow from UN agencies (US$) in Europe(developing only)?
Give a very brief answer. 2.42e+08. What is the difference between the highest and the second highest Aid flow from UN agencies (US$) of Mexico?
Make the answer very short. 5.00e+05. What is the difference between the highest and the second highest Aid flow from UN agencies (US$) of Swaziland?
Provide a succinct answer. 1.19e+06. What is the difference between the highest and the lowest Aid flow from UN agencies (US$) of Europe(developing only)?
Your answer should be very brief. 5.62e+08. What is the difference between the highest and the lowest Aid flow from UN agencies (US$) in Mexico?
Your answer should be very brief. 2.97e+06. What is the difference between the highest and the lowest Aid flow from UN agencies (US$) of Swaziland?
Your answer should be compact. 2.48e+06. 